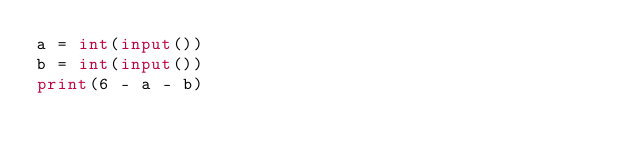<code> <loc_0><loc_0><loc_500><loc_500><_Python_>a = int(input())
b = int(input())
print(6 - a - b)</code> 